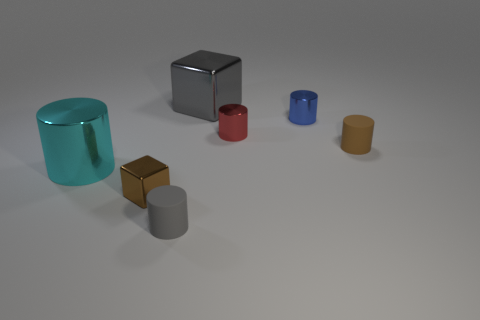There is a brown cylinder that is the same size as the red cylinder; what is its material?
Provide a succinct answer. Rubber. What number of things are either metal blocks that are on the left side of the gray shiny thing or large cyan rubber things?
Offer a terse response. 1. Are any small red things visible?
Give a very brief answer. Yes. There is a small brown object on the left side of the tiny brown matte cylinder; what is it made of?
Your answer should be very brief. Metal. There is a thing that is the same color as the big cube; what is it made of?
Keep it short and to the point. Rubber. How many big objects are blue metal things or matte blocks?
Your answer should be very brief. 0. The big cube has what color?
Offer a very short reply. Gray. There is a small gray cylinder that is in front of the tiny blue metal cylinder; is there a brown thing that is left of it?
Your answer should be compact. Yes. Are there fewer large gray blocks in front of the brown shiny thing than small green shiny blocks?
Your response must be concise. No. Are the tiny red object that is behind the tiny gray matte cylinder and the gray cylinder made of the same material?
Your answer should be compact. No. 